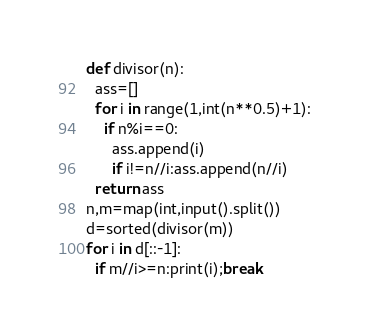Convert code to text. <code><loc_0><loc_0><loc_500><loc_500><_Python_>def divisor(n):
  ass=[]
  for i in range(1,int(n**0.5)+1):
    if n%i==0:
      ass.append(i)
      if i!=n//i:ass.append(n//i)
  return ass
n,m=map(int,input().split())
d=sorted(divisor(m))
for i in d[::-1]:
  if m//i>=n:print(i);break</code> 